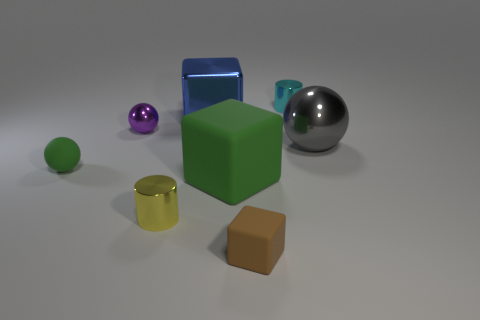There is a small thing that is behind the gray thing and to the left of the tiny cyan cylinder; what is its shape? sphere 